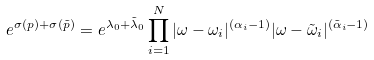<formula> <loc_0><loc_0><loc_500><loc_500>e ^ { \sigma ( p ) + \sigma ( \tilde { p } ) } = e ^ { \lambda _ { 0 } + \tilde { \lambda } _ { 0 } } \prod _ { i = 1 } ^ { N } | \omega - \omega _ { i } | ^ { ( \alpha _ { i } - 1 ) } | \omega - \tilde { \omega } _ { i } | ^ { ( \tilde { \alpha } _ { i } - 1 ) }</formula> 